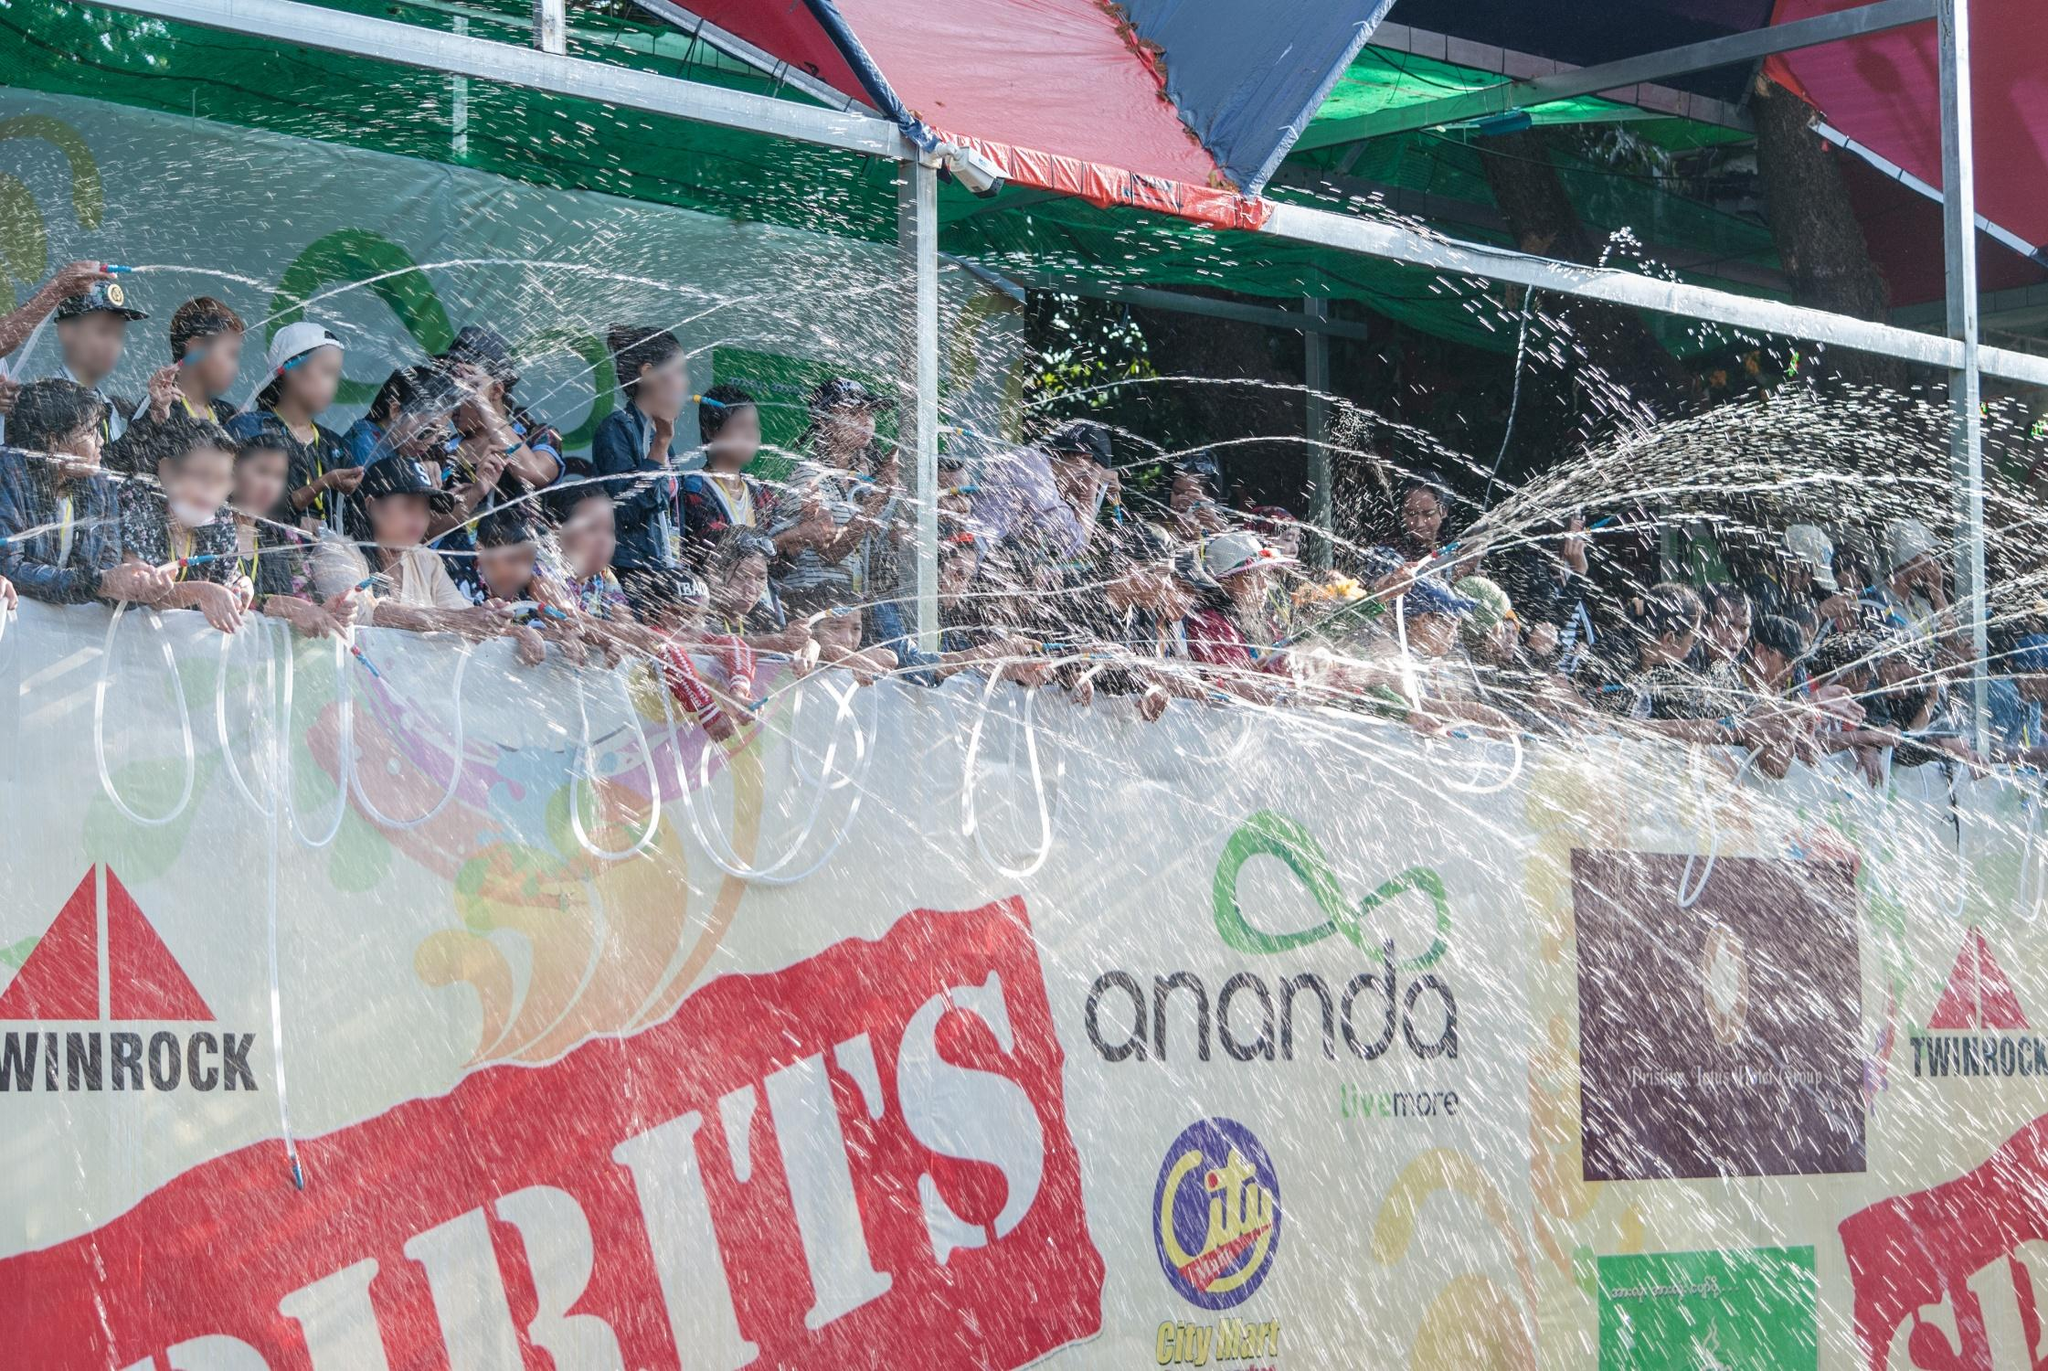If this event were to take place in a fantasy world, how would you imagine it? In a fantasy world, this event could take on an even more magical and surreal quality. Imagine the float being a majestic, floating ship gliding through the streets, not on wheels but on shimmering, ethereal clouds. The participants aboard the float might be mythical beings like elves, fairies, and water sprites, using enchanted water wands to create sparkling streams of water that dance in iridescent patterns as they cascade through the air. The water could have healing and rejuvenating properties, adding to the enchantment of the scene. The decorations on the float would include glowing runes and mythical symbols, with banners made of enchanted, shimmering fabric that changes colors in the light. The backdrop could be a sky illuminated by floating lanterns and magical fireworks that paint scenes of legends across the heavens. The crowd would be a diverse mix of fantastical creatures, all united in celebrating this magical festival, their laughter and music blending harmoniously to create an otherworldly atmosphere of pure joy and wonder. 